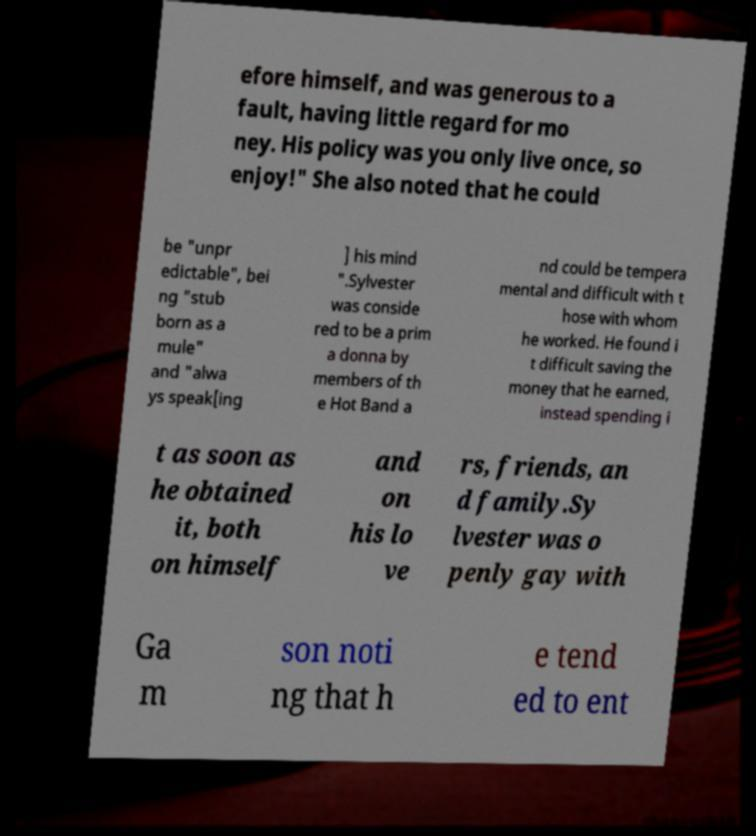Please identify and transcribe the text found in this image. efore himself, and was generous to a fault, having little regard for mo ney. His policy was you only live once, so enjoy!" She also noted that he could be "unpr edictable", bei ng "stub born as a mule" and "alwa ys speak[ing ] his mind ".Sylvester was conside red to be a prim a donna by members of th e Hot Band a nd could be tempera mental and difficult with t hose with whom he worked. He found i t difficult saving the money that he earned, instead spending i t as soon as he obtained it, both on himself and on his lo ve rs, friends, an d family.Sy lvester was o penly gay with Ga m son noti ng that h e tend ed to ent 